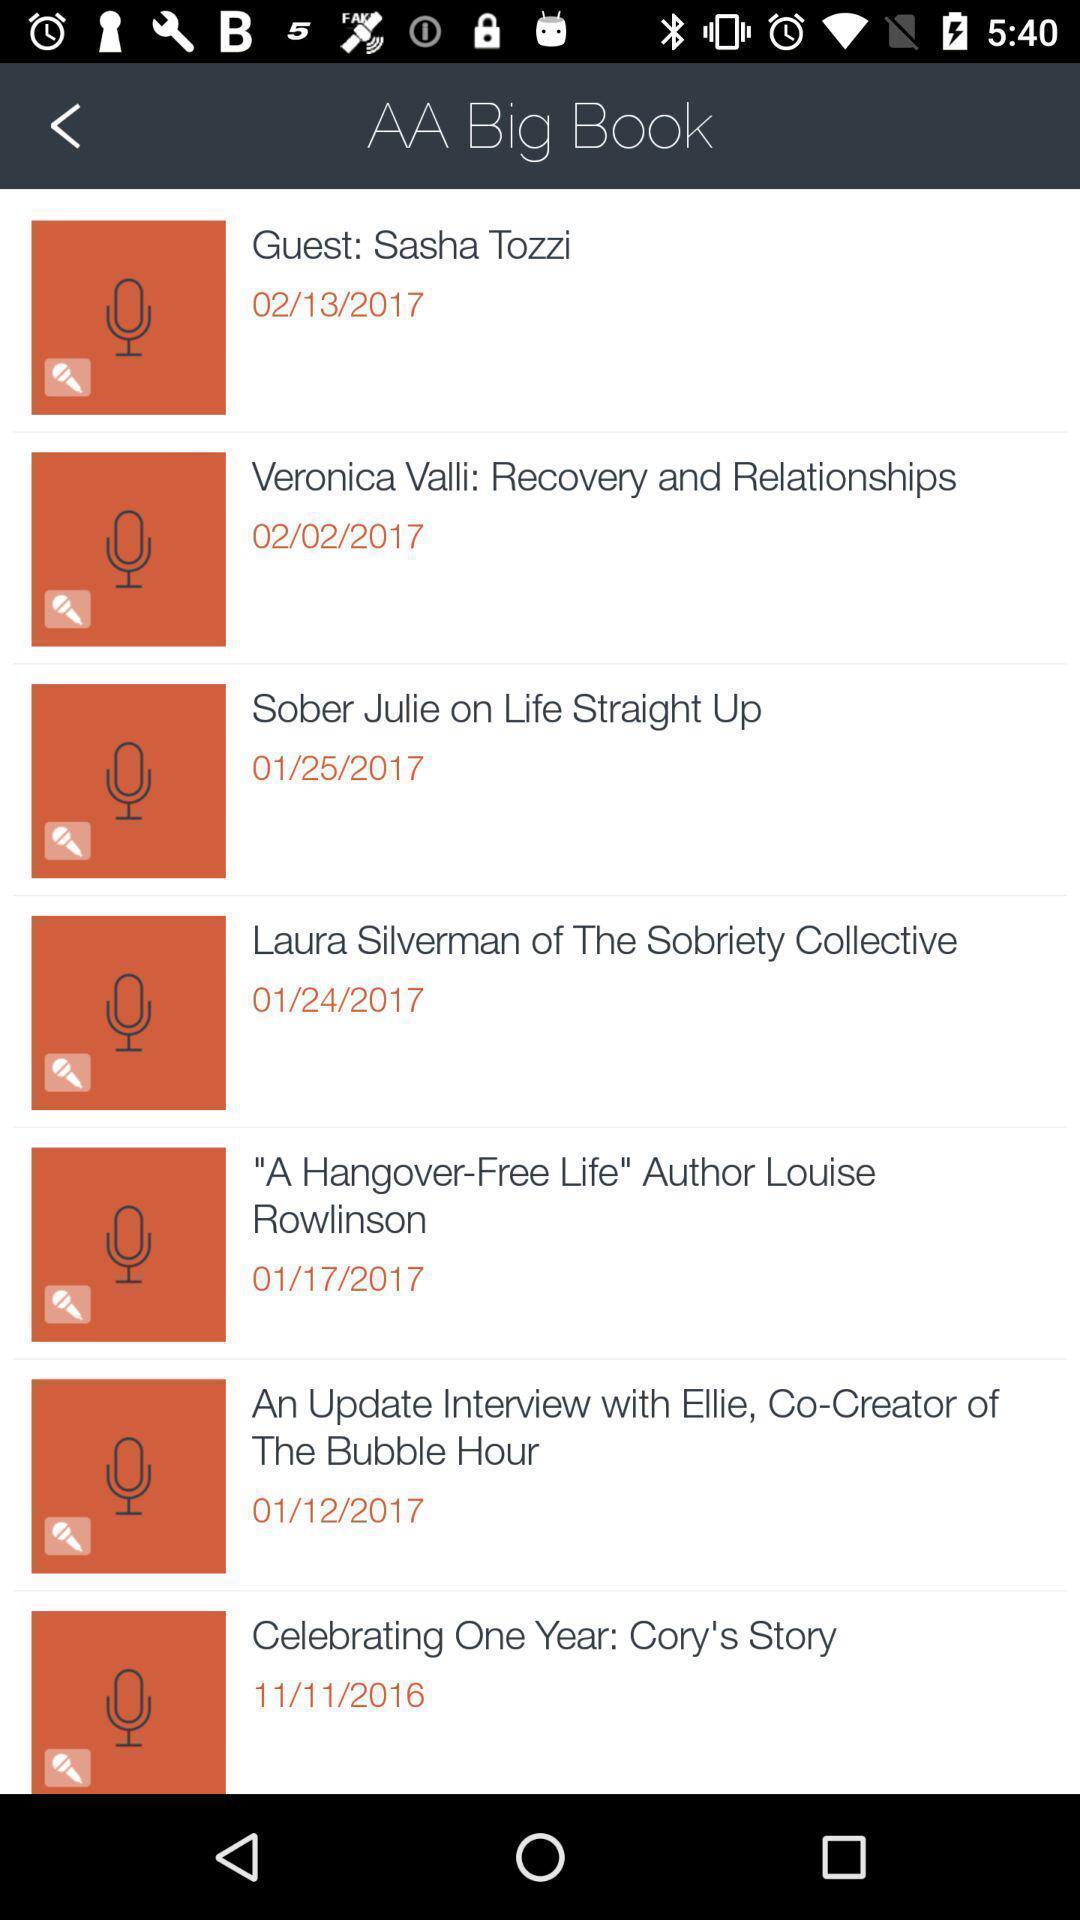Describe the key features of this screenshot. Page displaying with list of audios in application. 